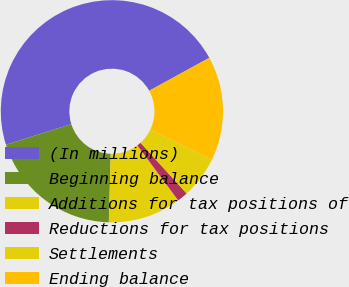Convert chart. <chart><loc_0><loc_0><loc_500><loc_500><pie_chart><fcel>(In millions)<fcel>Beginning balance<fcel>Additions for tax positions of<fcel>Reductions for tax positions<fcel>Settlements<fcel>Ending balance<nl><fcel>46.88%<fcel>19.69%<fcel>10.62%<fcel>1.56%<fcel>6.09%<fcel>15.16%<nl></chart> 